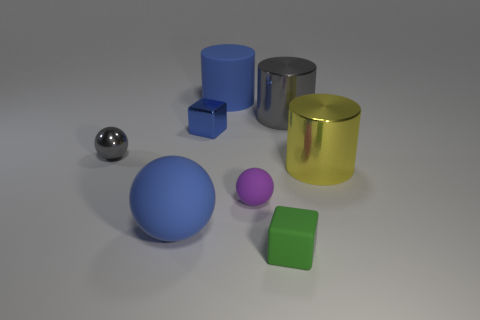Subtract all blue balls. How many balls are left? 2 Subtract all gray cylinders. How many cylinders are left? 2 Add 1 tiny purple matte things. How many objects exist? 9 Subtract all cylinders. How many objects are left? 5 Subtract 2 cubes. How many cubes are left? 0 Add 5 big blue rubber spheres. How many big blue rubber spheres are left? 6 Add 7 small blocks. How many small blocks exist? 9 Subtract 1 green blocks. How many objects are left? 7 Subtract all blue blocks. Subtract all purple cylinders. How many blocks are left? 1 Subtract all blue blocks. How many brown cylinders are left? 0 